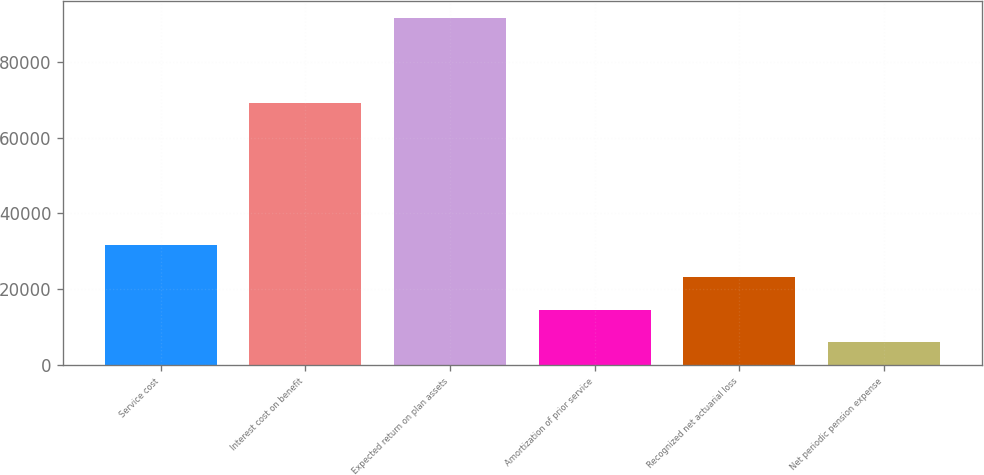Convert chart. <chart><loc_0><loc_0><loc_500><loc_500><bar_chart><fcel>Service cost<fcel>Interest cost on benefit<fcel>Expected return on plan assets<fcel>Amortization of prior service<fcel>Recognized net actuarial loss<fcel>Net periodic pension expense<nl><fcel>31709.6<fcel>69162<fcel>91568<fcel>14607.2<fcel>23158.4<fcel>6056<nl></chart> 